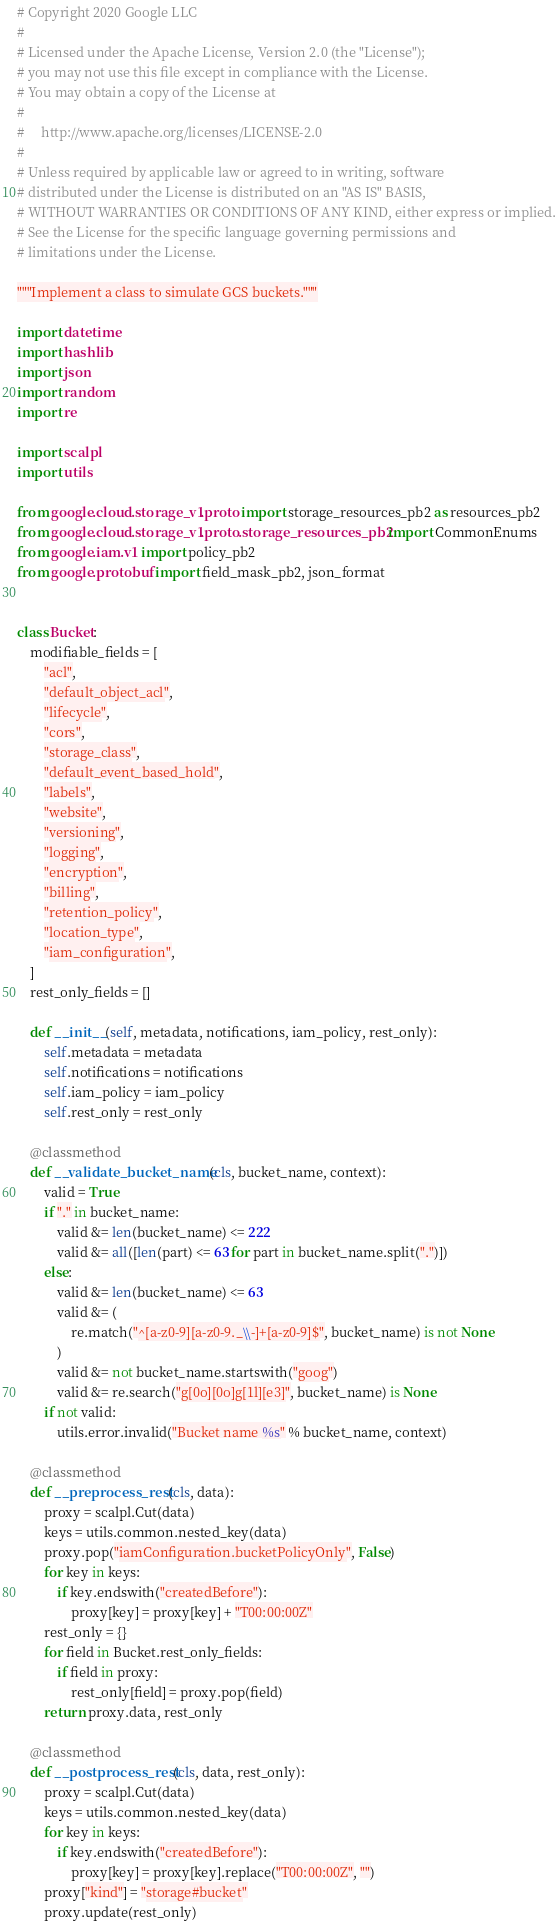Convert code to text. <code><loc_0><loc_0><loc_500><loc_500><_Python_># Copyright 2020 Google LLC
#
# Licensed under the Apache License, Version 2.0 (the "License");
# you may not use this file except in compliance with the License.
# You may obtain a copy of the License at
#
#     http://www.apache.org/licenses/LICENSE-2.0
#
# Unless required by applicable law or agreed to in writing, software
# distributed under the License is distributed on an "AS IS" BASIS,
# WITHOUT WARRANTIES OR CONDITIONS OF ANY KIND, either express or implied.
# See the License for the specific language governing permissions and
# limitations under the License.

"""Implement a class to simulate GCS buckets."""

import datetime
import hashlib
import json
import random
import re

import scalpl
import utils

from google.cloud.storage_v1.proto import storage_resources_pb2 as resources_pb2
from google.cloud.storage_v1.proto.storage_resources_pb2 import CommonEnums
from google.iam.v1 import policy_pb2
from google.protobuf import field_mask_pb2, json_format


class Bucket:
    modifiable_fields = [
        "acl",
        "default_object_acl",
        "lifecycle",
        "cors",
        "storage_class",
        "default_event_based_hold",
        "labels",
        "website",
        "versioning",
        "logging",
        "encryption",
        "billing",
        "retention_policy",
        "location_type",
        "iam_configuration",
    ]
    rest_only_fields = []

    def __init__(self, metadata, notifications, iam_policy, rest_only):
        self.metadata = metadata
        self.notifications = notifications
        self.iam_policy = iam_policy
        self.rest_only = rest_only

    @classmethod
    def __validate_bucket_name(cls, bucket_name, context):
        valid = True
        if "." in bucket_name:
            valid &= len(bucket_name) <= 222
            valid &= all([len(part) <= 63 for part in bucket_name.split(".")])
        else:
            valid &= len(bucket_name) <= 63
            valid &= (
                re.match("^[a-z0-9][a-z0-9._\\-]+[a-z0-9]$", bucket_name) is not None
            )
            valid &= not bucket_name.startswith("goog")
            valid &= re.search("g[0o][0o]g[1l][e3]", bucket_name) is None
        if not valid:
            utils.error.invalid("Bucket name %s" % bucket_name, context)

    @classmethod
    def __preprocess_rest(cls, data):
        proxy = scalpl.Cut(data)
        keys = utils.common.nested_key(data)
        proxy.pop("iamConfiguration.bucketPolicyOnly", False)
        for key in keys:
            if key.endswith("createdBefore"):
                proxy[key] = proxy[key] + "T00:00:00Z"
        rest_only = {}
        for field in Bucket.rest_only_fields:
            if field in proxy:
                rest_only[field] = proxy.pop(field)
        return proxy.data, rest_only

    @classmethod
    def __postprocess_rest(cls, data, rest_only):
        proxy = scalpl.Cut(data)
        keys = utils.common.nested_key(data)
        for key in keys:
            if key.endswith("createdBefore"):
                proxy[key] = proxy[key].replace("T00:00:00Z", "")
        proxy["kind"] = "storage#bucket"
        proxy.update(rest_only)</code> 